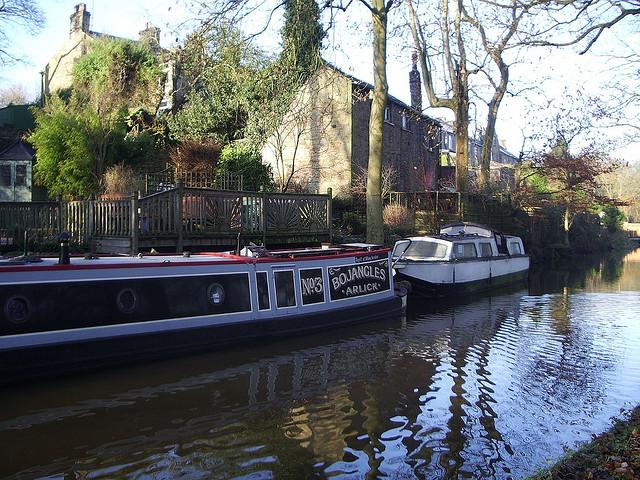What's in the water?
Be succinct. Boat. Is there fish in the water?
Answer briefly. Yes. What word is written in an arch style?
Keep it brief. Bojangles. 